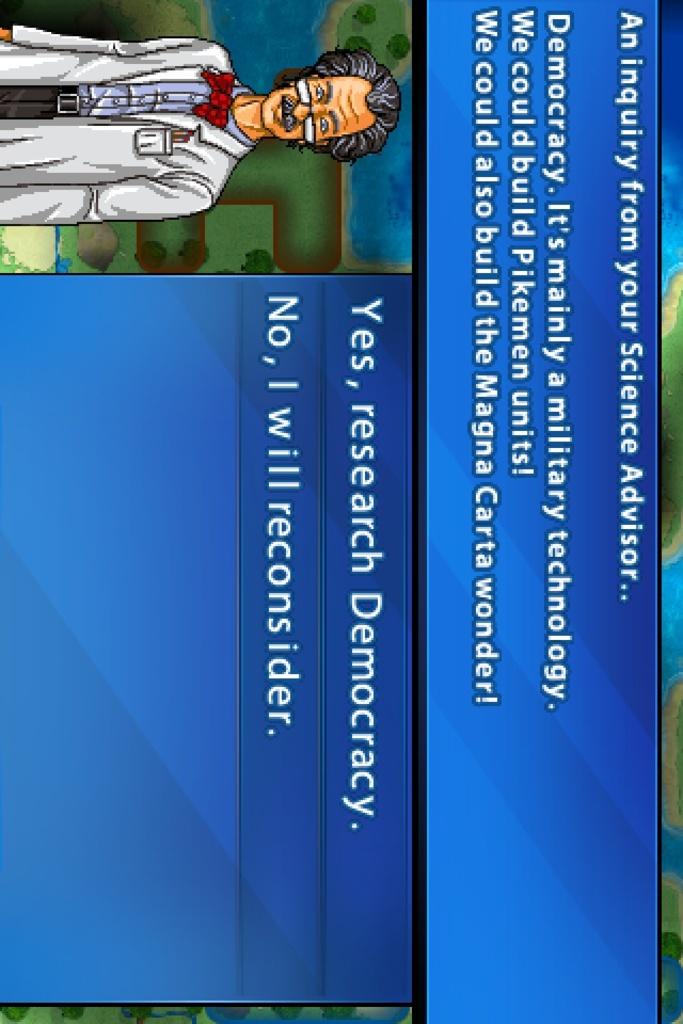What type of advisor is speaking?
Your answer should be compact. Science. 